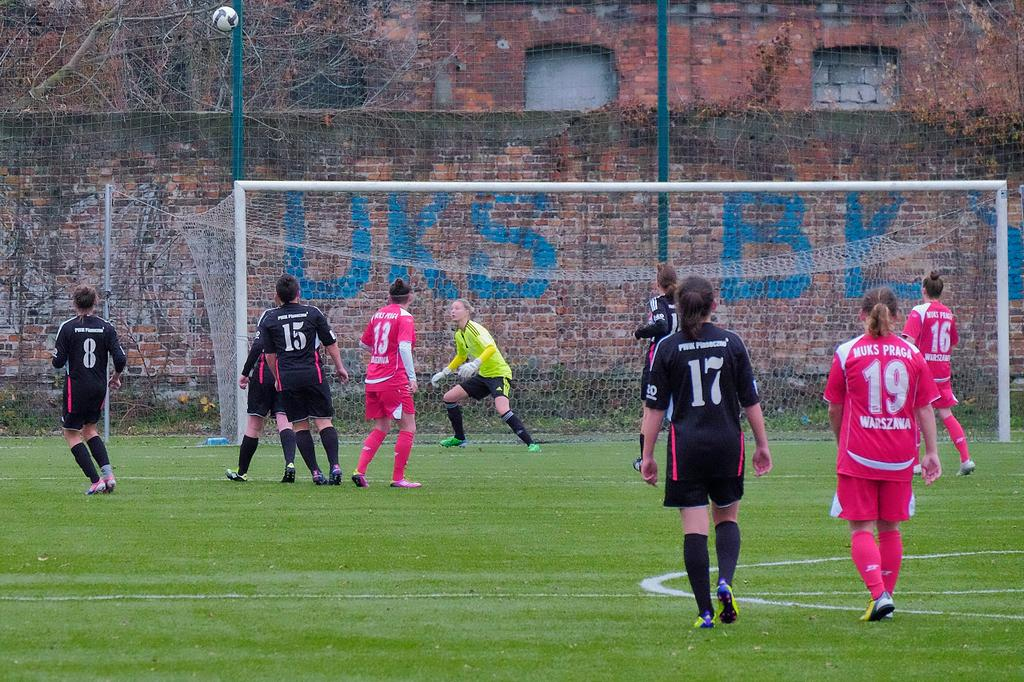<image>
Provide a brief description of the given image. Players 13, 16, and 19 are watching to see where the soccer ball will fall. 